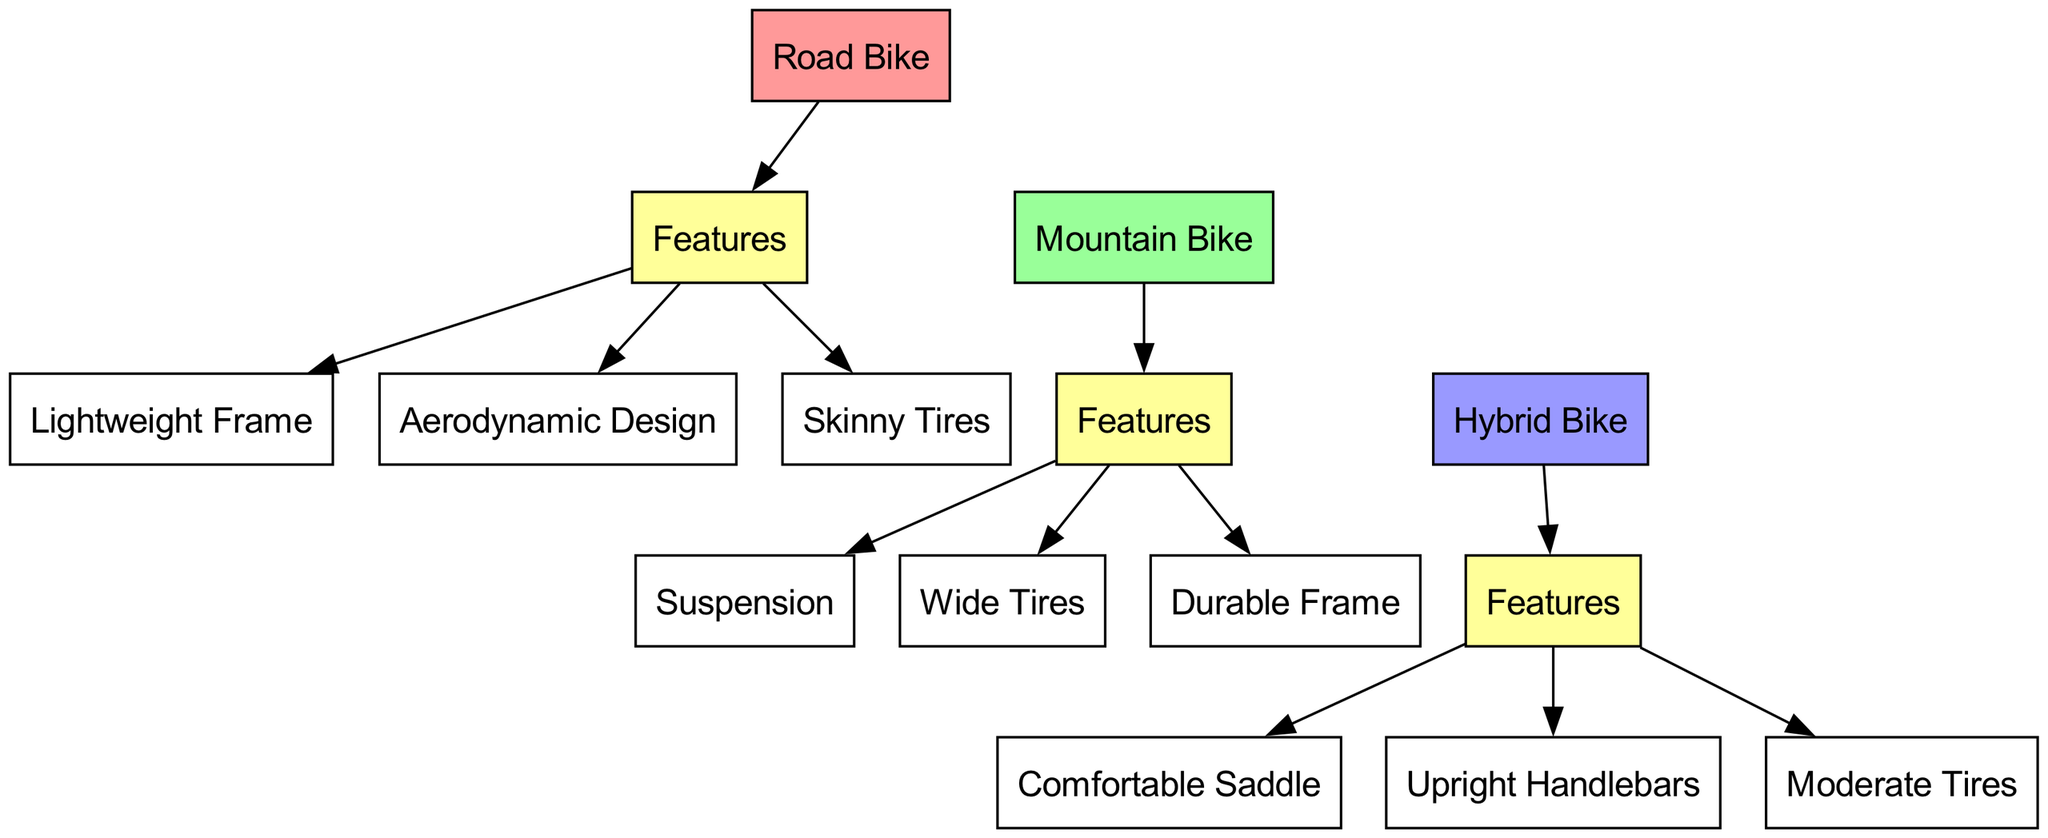What is the total number of bike types shown in the diagram? The diagram features three distinct bike types: Road Bike, Mountain Bike, and Hybrid Bike. Simply counting them results in a total of three bike types.
Answer: 3 What are the features associated with a Mountain Bike? The features connected to Mountain Bike are Suspension, Wide Tires, and Durable Frame. This can be identified in the diagram by tracing the connections from the Mountain Bike node to its feature nodes.
Answer: Suspension, Wide Tires, Durable Frame Which bike type has the feature 'Skinny Tires'? The feature 'Skinny Tires' is linked to the Road Bike node in the diagram. One can follow the line from Road Bike to its features to find this information.
Answer: Road Bike How many features are listed for Hybrid Bike? There are three features corresponding to Hybrid Bike: Comfortable Saddle, Upright Handlebars, and Moderate Tires, which can be determined by examining the edges leading from the Hybrid Bike node to its respective features.
Answer: 3 Which bike type has a feature that provides a 'Durable Frame'? The feature 'Durable Frame' is associated with the Mountain Bike. This can be verified by following the connections from the Mountain Bike node to its features in the diagram.
Answer: Mountain Bike What color represents the features in the diagram? The features in the diagram are represented by the color yellow (#FFFF99), which is specified in the color scheme defined within the diagram's code.
Answer: Yellow What is the relationship between Road Bike and its features? Road Bike is directly connected to the Features node, which in turn branches out to specific features: Lightweight Frame, Aerodynamic Design, and Skinny Tires. The relationship is hierarchical, with Road Bike at the top leading to its characteristics.
Answer: Hierarchical Which bike type does not utilize Skinny Tires? The Mountain Bike and Hybrid Bike do not utilize Skinny Tires, as this feature is only linked to the Road Bike. Therefore, both other bike types can be identified as not using this characteristic.
Answer: Mountain Bike, Hybrid Bike How many edges originate from the Hybrid Bike? The edges originating from the Hybrid Bike are three: one each to Comfortable Saddle, Upright Handlebars, and Moderate Tires. The number of edges emanating from the Hybrid Bike can be counted by checking the connections leading away from its node.
Answer: 3 